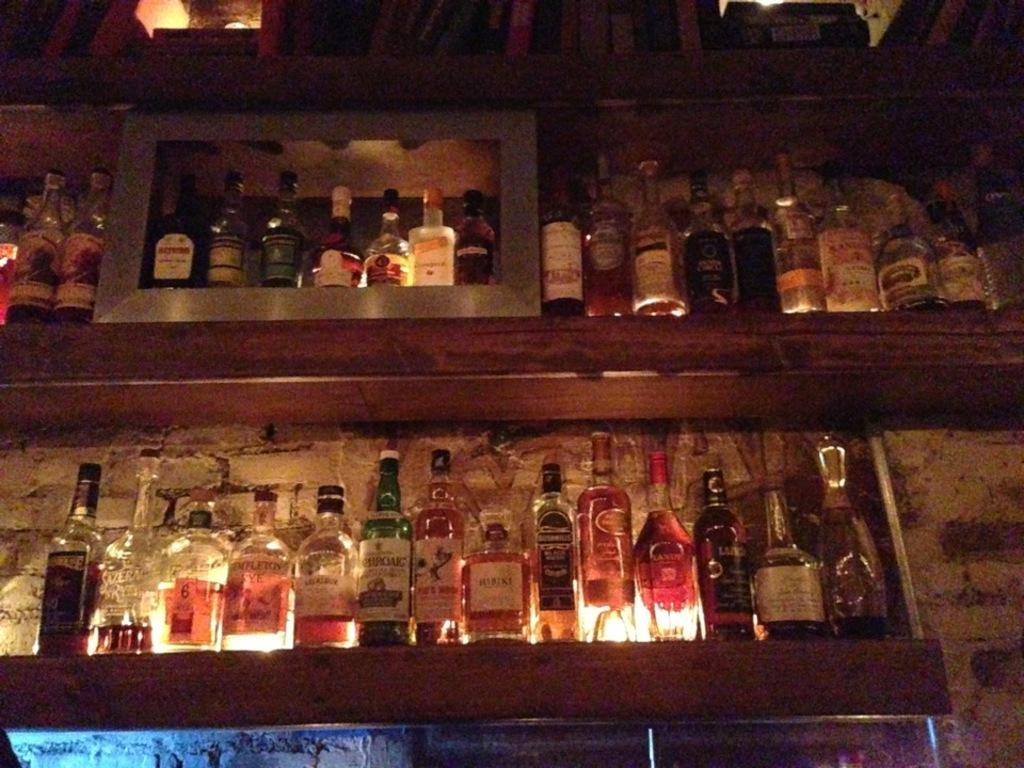What can be seen arranged on shelves in the image? There are bottles arranged on shelves in the image. Can you describe the bottle located in the middle of the image? There is a bottle with a green color in the middle of the image. What are the bottles filled with? The bottles are filled with drinks. How much steam is coming out of the bottles in the image? There is no steam coming out of the bottles in the image, as they are filled with drinks and not hot liquids. 